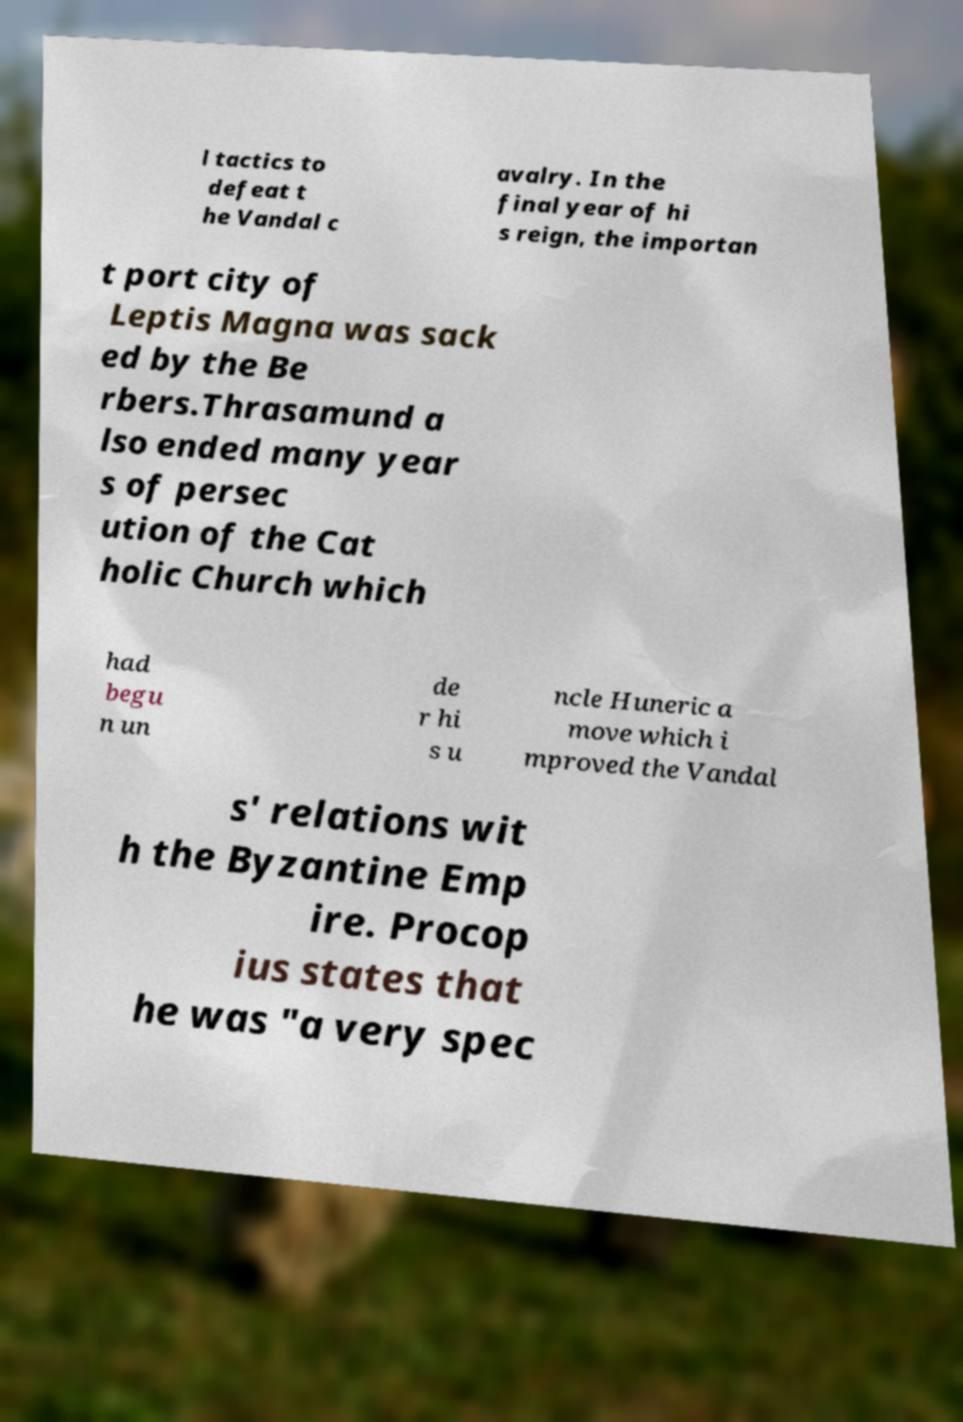What messages or text are displayed in this image? I need them in a readable, typed format. l tactics to defeat t he Vandal c avalry. In the final year of hi s reign, the importan t port city of Leptis Magna was sack ed by the Be rbers.Thrasamund a lso ended many year s of persec ution of the Cat holic Church which had begu n un de r hi s u ncle Huneric a move which i mproved the Vandal s' relations wit h the Byzantine Emp ire. Procop ius states that he was "a very spec 